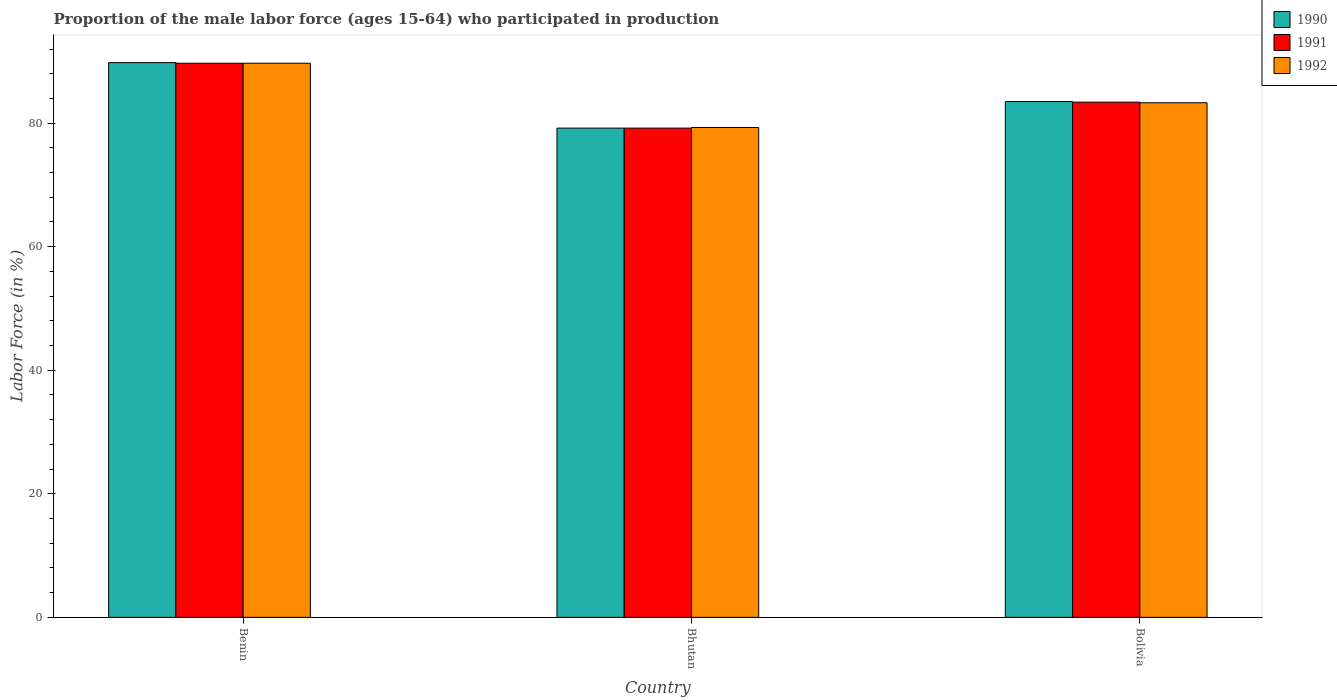How many different coloured bars are there?
Offer a very short reply. 3. How many groups of bars are there?
Offer a terse response. 3. How many bars are there on the 3rd tick from the left?
Give a very brief answer. 3. How many bars are there on the 1st tick from the right?
Give a very brief answer. 3. What is the label of the 3rd group of bars from the left?
Ensure brevity in your answer.  Bolivia. What is the proportion of the male labor force who participated in production in 1991 in Benin?
Ensure brevity in your answer.  89.7. Across all countries, what is the maximum proportion of the male labor force who participated in production in 1992?
Give a very brief answer. 89.7. Across all countries, what is the minimum proportion of the male labor force who participated in production in 1991?
Offer a terse response. 79.2. In which country was the proportion of the male labor force who participated in production in 1992 maximum?
Keep it short and to the point. Benin. In which country was the proportion of the male labor force who participated in production in 1990 minimum?
Your answer should be very brief. Bhutan. What is the total proportion of the male labor force who participated in production in 1990 in the graph?
Your response must be concise. 252.5. What is the difference between the proportion of the male labor force who participated in production in 1991 in Benin and that in Bolivia?
Your answer should be very brief. 6.3. What is the difference between the proportion of the male labor force who participated in production in 1992 in Bolivia and the proportion of the male labor force who participated in production in 1990 in Bhutan?
Ensure brevity in your answer.  4.1. What is the average proportion of the male labor force who participated in production in 1992 per country?
Offer a terse response. 84.1. In how many countries, is the proportion of the male labor force who participated in production in 1991 greater than 52 %?
Provide a succinct answer. 3. What is the ratio of the proportion of the male labor force who participated in production in 1990 in Benin to that in Bolivia?
Your response must be concise. 1.08. Is the difference between the proportion of the male labor force who participated in production in 1992 in Bhutan and Bolivia greater than the difference between the proportion of the male labor force who participated in production in 1991 in Bhutan and Bolivia?
Make the answer very short. Yes. What is the difference between the highest and the second highest proportion of the male labor force who participated in production in 1990?
Your answer should be very brief. 6.3. What is the difference between the highest and the lowest proportion of the male labor force who participated in production in 1992?
Offer a very short reply. 10.4. In how many countries, is the proportion of the male labor force who participated in production in 1992 greater than the average proportion of the male labor force who participated in production in 1992 taken over all countries?
Provide a short and direct response. 1. Is the sum of the proportion of the male labor force who participated in production in 1991 in Benin and Bolivia greater than the maximum proportion of the male labor force who participated in production in 1990 across all countries?
Offer a very short reply. Yes. What does the 1st bar from the right in Benin represents?
Provide a short and direct response. 1992. Is it the case that in every country, the sum of the proportion of the male labor force who participated in production in 1992 and proportion of the male labor force who participated in production in 1991 is greater than the proportion of the male labor force who participated in production in 1990?
Provide a short and direct response. Yes. How many bars are there?
Give a very brief answer. 9. Are all the bars in the graph horizontal?
Offer a very short reply. No. What is the difference between two consecutive major ticks on the Y-axis?
Provide a succinct answer. 20. Does the graph contain any zero values?
Your response must be concise. No. Does the graph contain grids?
Offer a very short reply. No. How many legend labels are there?
Provide a succinct answer. 3. What is the title of the graph?
Keep it short and to the point. Proportion of the male labor force (ages 15-64) who participated in production. What is the Labor Force (in %) in 1990 in Benin?
Keep it short and to the point. 89.8. What is the Labor Force (in %) of 1991 in Benin?
Provide a short and direct response. 89.7. What is the Labor Force (in %) of 1992 in Benin?
Your answer should be compact. 89.7. What is the Labor Force (in %) in 1990 in Bhutan?
Provide a succinct answer. 79.2. What is the Labor Force (in %) in 1991 in Bhutan?
Offer a very short reply. 79.2. What is the Labor Force (in %) in 1992 in Bhutan?
Make the answer very short. 79.3. What is the Labor Force (in %) of 1990 in Bolivia?
Offer a terse response. 83.5. What is the Labor Force (in %) in 1991 in Bolivia?
Make the answer very short. 83.4. What is the Labor Force (in %) of 1992 in Bolivia?
Offer a very short reply. 83.3. Across all countries, what is the maximum Labor Force (in %) in 1990?
Provide a short and direct response. 89.8. Across all countries, what is the maximum Labor Force (in %) of 1991?
Provide a short and direct response. 89.7. Across all countries, what is the maximum Labor Force (in %) in 1992?
Your answer should be very brief. 89.7. Across all countries, what is the minimum Labor Force (in %) of 1990?
Offer a terse response. 79.2. Across all countries, what is the minimum Labor Force (in %) of 1991?
Provide a short and direct response. 79.2. Across all countries, what is the minimum Labor Force (in %) in 1992?
Ensure brevity in your answer.  79.3. What is the total Labor Force (in %) in 1990 in the graph?
Keep it short and to the point. 252.5. What is the total Labor Force (in %) of 1991 in the graph?
Give a very brief answer. 252.3. What is the total Labor Force (in %) in 1992 in the graph?
Your answer should be very brief. 252.3. What is the difference between the Labor Force (in %) of 1991 in Benin and that in Bhutan?
Make the answer very short. 10.5. What is the difference between the Labor Force (in %) of 1992 in Benin and that in Bhutan?
Your response must be concise. 10.4. What is the difference between the Labor Force (in %) in 1992 in Benin and that in Bolivia?
Provide a short and direct response. 6.4. What is the difference between the Labor Force (in %) in 1990 in Bhutan and that in Bolivia?
Ensure brevity in your answer.  -4.3. What is the difference between the Labor Force (in %) in 1992 in Bhutan and that in Bolivia?
Offer a very short reply. -4. What is the difference between the Labor Force (in %) of 1990 in Benin and the Labor Force (in %) of 1992 in Bhutan?
Ensure brevity in your answer.  10.5. What is the difference between the Labor Force (in %) in 1991 in Benin and the Labor Force (in %) in 1992 in Bhutan?
Keep it short and to the point. 10.4. What is the difference between the Labor Force (in %) in 1990 in Benin and the Labor Force (in %) in 1991 in Bolivia?
Your answer should be compact. 6.4. What is the difference between the Labor Force (in %) in 1990 in Benin and the Labor Force (in %) in 1992 in Bolivia?
Your answer should be very brief. 6.5. What is the difference between the Labor Force (in %) of 1991 in Benin and the Labor Force (in %) of 1992 in Bolivia?
Ensure brevity in your answer.  6.4. What is the difference between the Labor Force (in %) in 1990 in Bhutan and the Labor Force (in %) in 1992 in Bolivia?
Provide a short and direct response. -4.1. What is the average Labor Force (in %) of 1990 per country?
Your answer should be compact. 84.17. What is the average Labor Force (in %) of 1991 per country?
Your answer should be very brief. 84.1. What is the average Labor Force (in %) of 1992 per country?
Your answer should be compact. 84.1. What is the difference between the Labor Force (in %) in 1990 and Labor Force (in %) in 1992 in Benin?
Offer a terse response. 0.1. What is the difference between the Labor Force (in %) of 1991 and Labor Force (in %) of 1992 in Benin?
Give a very brief answer. 0. What is the difference between the Labor Force (in %) in 1991 and Labor Force (in %) in 1992 in Bhutan?
Ensure brevity in your answer.  -0.1. What is the difference between the Labor Force (in %) in 1990 and Labor Force (in %) in 1991 in Bolivia?
Ensure brevity in your answer.  0.1. What is the ratio of the Labor Force (in %) in 1990 in Benin to that in Bhutan?
Ensure brevity in your answer.  1.13. What is the ratio of the Labor Force (in %) of 1991 in Benin to that in Bhutan?
Provide a short and direct response. 1.13. What is the ratio of the Labor Force (in %) in 1992 in Benin to that in Bhutan?
Your answer should be very brief. 1.13. What is the ratio of the Labor Force (in %) of 1990 in Benin to that in Bolivia?
Offer a very short reply. 1.08. What is the ratio of the Labor Force (in %) in 1991 in Benin to that in Bolivia?
Offer a terse response. 1.08. What is the ratio of the Labor Force (in %) in 1992 in Benin to that in Bolivia?
Make the answer very short. 1.08. What is the ratio of the Labor Force (in %) of 1990 in Bhutan to that in Bolivia?
Your response must be concise. 0.95. What is the ratio of the Labor Force (in %) in 1991 in Bhutan to that in Bolivia?
Offer a very short reply. 0.95. What is the difference between the highest and the second highest Labor Force (in %) in 1990?
Provide a short and direct response. 6.3. What is the difference between the highest and the second highest Labor Force (in %) in 1991?
Offer a very short reply. 6.3. What is the difference between the highest and the lowest Labor Force (in %) in 1990?
Your response must be concise. 10.6. What is the difference between the highest and the lowest Labor Force (in %) in 1991?
Ensure brevity in your answer.  10.5. What is the difference between the highest and the lowest Labor Force (in %) in 1992?
Ensure brevity in your answer.  10.4. 